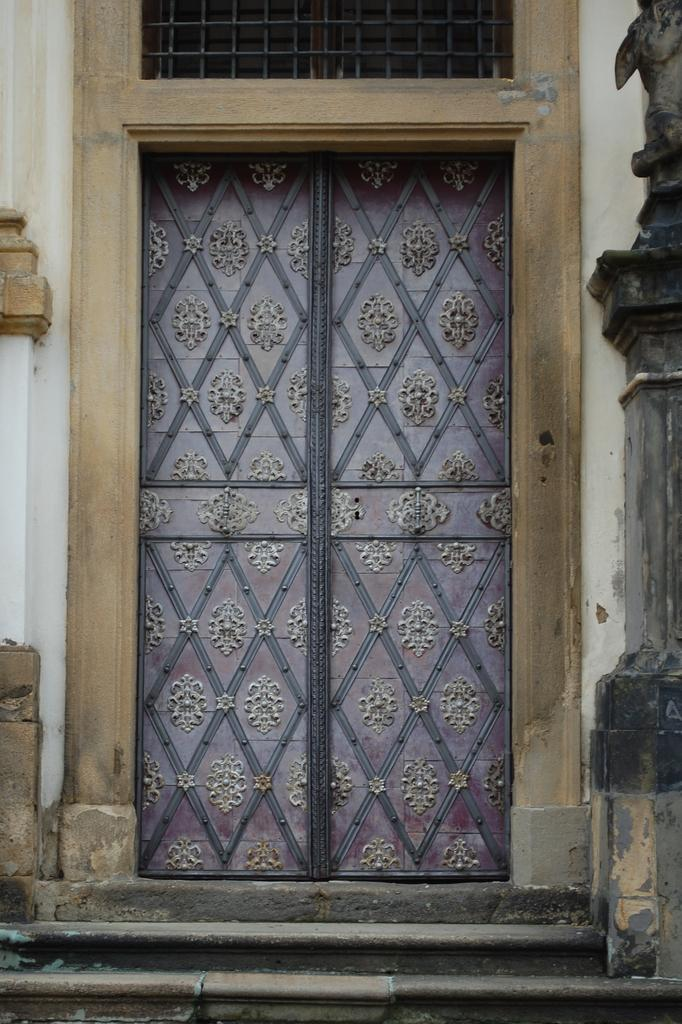What architectural feature is present in the image? There is a door in the image. What can be seen at the front of the image? There are stairs at the front in the image. What supports the structure on either side in the image? There are pillars on either side in the image. How many tomatoes are on the visitor's decision in the image? There are no tomatoes, visitors, or decisions present in the image. 